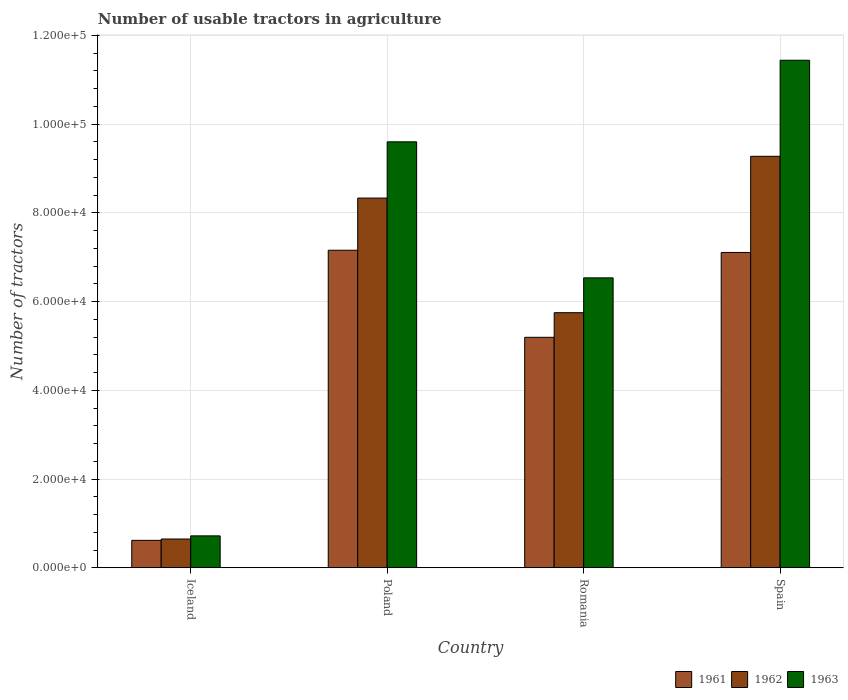How many different coloured bars are there?
Keep it short and to the point. 3. How many bars are there on the 3rd tick from the right?
Your answer should be compact. 3. In how many cases, is the number of bars for a given country not equal to the number of legend labels?
Make the answer very short. 0. What is the number of usable tractors in agriculture in 1963 in Poland?
Make the answer very short. 9.60e+04. Across all countries, what is the maximum number of usable tractors in agriculture in 1961?
Provide a short and direct response. 7.16e+04. Across all countries, what is the minimum number of usable tractors in agriculture in 1961?
Offer a very short reply. 6177. In which country was the number of usable tractors in agriculture in 1961 maximum?
Offer a terse response. Poland. What is the total number of usable tractors in agriculture in 1963 in the graph?
Offer a very short reply. 2.83e+05. What is the difference between the number of usable tractors in agriculture in 1963 in Poland and that in Spain?
Your answer should be compact. -1.84e+04. What is the difference between the number of usable tractors in agriculture in 1961 in Spain and the number of usable tractors in agriculture in 1963 in Romania?
Offer a very short reply. 5726. What is the average number of usable tractors in agriculture in 1961 per country?
Provide a succinct answer. 5.02e+04. What is the difference between the number of usable tractors in agriculture of/in 1963 and number of usable tractors in agriculture of/in 1962 in Spain?
Your answer should be compact. 2.17e+04. In how many countries, is the number of usable tractors in agriculture in 1962 greater than 64000?
Give a very brief answer. 2. What is the ratio of the number of usable tractors in agriculture in 1963 in Iceland to that in Poland?
Make the answer very short. 0.07. Is the number of usable tractors in agriculture in 1962 in Iceland less than that in Poland?
Make the answer very short. Yes. Is the difference between the number of usable tractors in agriculture in 1963 in Poland and Spain greater than the difference between the number of usable tractors in agriculture in 1962 in Poland and Spain?
Your answer should be very brief. No. What is the difference between the highest and the second highest number of usable tractors in agriculture in 1962?
Give a very brief answer. 3.53e+04. What is the difference between the highest and the lowest number of usable tractors in agriculture in 1962?
Offer a very short reply. 8.63e+04. What does the 1st bar from the right in Iceland represents?
Your response must be concise. 1963. Is it the case that in every country, the sum of the number of usable tractors in agriculture in 1962 and number of usable tractors in agriculture in 1961 is greater than the number of usable tractors in agriculture in 1963?
Provide a succinct answer. Yes. Are all the bars in the graph horizontal?
Offer a very short reply. No. What is the difference between two consecutive major ticks on the Y-axis?
Your answer should be compact. 2.00e+04. Are the values on the major ticks of Y-axis written in scientific E-notation?
Provide a succinct answer. Yes. Does the graph contain any zero values?
Keep it short and to the point. No. Does the graph contain grids?
Keep it short and to the point. Yes. Where does the legend appear in the graph?
Offer a very short reply. Bottom right. What is the title of the graph?
Keep it short and to the point. Number of usable tractors in agriculture. Does "1992" appear as one of the legend labels in the graph?
Your answer should be compact. No. What is the label or title of the Y-axis?
Offer a very short reply. Number of tractors. What is the Number of tractors of 1961 in Iceland?
Your answer should be compact. 6177. What is the Number of tractors in 1962 in Iceland?
Offer a terse response. 6479. What is the Number of tractors of 1963 in Iceland?
Keep it short and to the point. 7187. What is the Number of tractors in 1961 in Poland?
Offer a very short reply. 7.16e+04. What is the Number of tractors in 1962 in Poland?
Your answer should be very brief. 8.33e+04. What is the Number of tractors of 1963 in Poland?
Your answer should be compact. 9.60e+04. What is the Number of tractors of 1961 in Romania?
Ensure brevity in your answer.  5.20e+04. What is the Number of tractors of 1962 in Romania?
Make the answer very short. 5.75e+04. What is the Number of tractors in 1963 in Romania?
Your response must be concise. 6.54e+04. What is the Number of tractors in 1961 in Spain?
Provide a succinct answer. 7.11e+04. What is the Number of tractors of 1962 in Spain?
Offer a very short reply. 9.28e+04. What is the Number of tractors of 1963 in Spain?
Ensure brevity in your answer.  1.14e+05. Across all countries, what is the maximum Number of tractors in 1961?
Offer a very short reply. 7.16e+04. Across all countries, what is the maximum Number of tractors of 1962?
Your answer should be compact. 9.28e+04. Across all countries, what is the maximum Number of tractors in 1963?
Provide a short and direct response. 1.14e+05. Across all countries, what is the minimum Number of tractors in 1961?
Your answer should be very brief. 6177. Across all countries, what is the minimum Number of tractors in 1962?
Provide a short and direct response. 6479. Across all countries, what is the minimum Number of tractors of 1963?
Give a very brief answer. 7187. What is the total Number of tractors in 1961 in the graph?
Provide a succinct answer. 2.01e+05. What is the total Number of tractors of 1962 in the graph?
Provide a short and direct response. 2.40e+05. What is the total Number of tractors of 1963 in the graph?
Your answer should be very brief. 2.83e+05. What is the difference between the Number of tractors in 1961 in Iceland and that in Poland?
Provide a short and direct response. -6.54e+04. What is the difference between the Number of tractors in 1962 in Iceland and that in Poland?
Keep it short and to the point. -7.69e+04. What is the difference between the Number of tractors of 1963 in Iceland and that in Poland?
Keep it short and to the point. -8.88e+04. What is the difference between the Number of tractors in 1961 in Iceland and that in Romania?
Your answer should be very brief. -4.58e+04. What is the difference between the Number of tractors in 1962 in Iceland and that in Romania?
Provide a succinct answer. -5.10e+04. What is the difference between the Number of tractors of 1963 in Iceland and that in Romania?
Give a very brief answer. -5.82e+04. What is the difference between the Number of tractors in 1961 in Iceland and that in Spain?
Provide a short and direct response. -6.49e+04. What is the difference between the Number of tractors in 1962 in Iceland and that in Spain?
Provide a succinct answer. -8.63e+04. What is the difference between the Number of tractors in 1963 in Iceland and that in Spain?
Keep it short and to the point. -1.07e+05. What is the difference between the Number of tractors of 1961 in Poland and that in Romania?
Your answer should be compact. 1.96e+04. What is the difference between the Number of tractors in 1962 in Poland and that in Romania?
Provide a succinct answer. 2.58e+04. What is the difference between the Number of tractors of 1963 in Poland and that in Romania?
Provide a succinct answer. 3.07e+04. What is the difference between the Number of tractors of 1962 in Poland and that in Spain?
Make the answer very short. -9414. What is the difference between the Number of tractors of 1963 in Poland and that in Spain?
Your answer should be very brief. -1.84e+04. What is the difference between the Number of tractors in 1961 in Romania and that in Spain?
Your answer should be compact. -1.91e+04. What is the difference between the Number of tractors of 1962 in Romania and that in Spain?
Your response must be concise. -3.53e+04. What is the difference between the Number of tractors in 1963 in Romania and that in Spain?
Your answer should be compact. -4.91e+04. What is the difference between the Number of tractors in 1961 in Iceland and the Number of tractors in 1962 in Poland?
Your response must be concise. -7.72e+04. What is the difference between the Number of tractors in 1961 in Iceland and the Number of tractors in 1963 in Poland?
Offer a terse response. -8.98e+04. What is the difference between the Number of tractors in 1962 in Iceland and the Number of tractors in 1963 in Poland?
Your answer should be very brief. -8.95e+04. What is the difference between the Number of tractors in 1961 in Iceland and the Number of tractors in 1962 in Romania?
Ensure brevity in your answer.  -5.13e+04. What is the difference between the Number of tractors of 1961 in Iceland and the Number of tractors of 1963 in Romania?
Keep it short and to the point. -5.92e+04. What is the difference between the Number of tractors of 1962 in Iceland and the Number of tractors of 1963 in Romania?
Offer a terse response. -5.89e+04. What is the difference between the Number of tractors in 1961 in Iceland and the Number of tractors in 1962 in Spain?
Ensure brevity in your answer.  -8.66e+04. What is the difference between the Number of tractors in 1961 in Iceland and the Number of tractors in 1963 in Spain?
Offer a very short reply. -1.08e+05. What is the difference between the Number of tractors in 1962 in Iceland and the Number of tractors in 1963 in Spain?
Your response must be concise. -1.08e+05. What is the difference between the Number of tractors in 1961 in Poland and the Number of tractors in 1962 in Romania?
Provide a short and direct response. 1.41e+04. What is the difference between the Number of tractors in 1961 in Poland and the Number of tractors in 1963 in Romania?
Keep it short and to the point. 6226. What is the difference between the Number of tractors in 1962 in Poland and the Number of tractors in 1963 in Romania?
Provide a succinct answer. 1.80e+04. What is the difference between the Number of tractors in 1961 in Poland and the Number of tractors in 1962 in Spain?
Provide a short and direct response. -2.12e+04. What is the difference between the Number of tractors of 1961 in Poland and the Number of tractors of 1963 in Spain?
Offer a very short reply. -4.28e+04. What is the difference between the Number of tractors of 1962 in Poland and the Number of tractors of 1963 in Spain?
Make the answer very short. -3.11e+04. What is the difference between the Number of tractors in 1961 in Romania and the Number of tractors in 1962 in Spain?
Your response must be concise. -4.08e+04. What is the difference between the Number of tractors of 1961 in Romania and the Number of tractors of 1963 in Spain?
Ensure brevity in your answer.  -6.25e+04. What is the difference between the Number of tractors of 1962 in Romania and the Number of tractors of 1963 in Spain?
Ensure brevity in your answer.  -5.69e+04. What is the average Number of tractors of 1961 per country?
Give a very brief answer. 5.02e+04. What is the average Number of tractors of 1962 per country?
Make the answer very short. 6.00e+04. What is the average Number of tractors in 1963 per country?
Give a very brief answer. 7.07e+04. What is the difference between the Number of tractors of 1961 and Number of tractors of 1962 in Iceland?
Your response must be concise. -302. What is the difference between the Number of tractors of 1961 and Number of tractors of 1963 in Iceland?
Ensure brevity in your answer.  -1010. What is the difference between the Number of tractors of 1962 and Number of tractors of 1963 in Iceland?
Ensure brevity in your answer.  -708. What is the difference between the Number of tractors in 1961 and Number of tractors in 1962 in Poland?
Offer a terse response. -1.18e+04. What is the difference between the Number of tractors of 1961 and Number of tractors of 1963 in Poland?
Provide a succinct answer. -2.44e+04. What is the difference between the Number of tractors of 1962 and Number of tractors of 1963 in Poland?
Ensure brevity in your answer.  -1.27e+04. What is the difference between the Number of tractors in 1961 and Number of tractors in 1962 in Romania?
Make the answer very short. -5548. What is the difference between the Number of tractors in 1961 and Number of tractors in 1963 in Romania?
Provide a short and direct response. -1.34e+04. What is the difference between the Number of tractors of 1962 and Number of tractors of 1963 in Romania?
Provide a succinct answer. -7851. What is the difference between the Number of tractors in 1961 and Number of tractors in 1962 in Spain?
Give a very brief answer. -2.17e+04. What is the difference between the Number of tractors in 1961 and Number of tractors in 1963 in Spain?
Keep it short and to the point. -4.33e+04. What is the difference between the Number of tractors of 1962 and Number of tractors of 1963 in Spain?
Offer a terse response. -2.17e+04. What is the ratio of the Number of tractors of 1961 in Iceland to that in Poland?
Provide a short and direct response. 0.09. What is the ratio of the Number of tractors of 1962 in Iceland to that in Poland?
Your response must be concise. 0.08. What is the ratio of the Number of tractors in 1963 in Iceland to that in Poland?
Provide a short and direct response. 0.07. What is the ratio of the Number of tractors in 1961 in Iceland to that in Romania?
Offer a terse response. 0.12. What is the ratio of the Number of tractors in 1962 in Iceland to that in Romania?
Make the answer very short. 0.11. What is the ratio of the Number of tractors of 1963 in Iceland to that in Romania?
Your response must be concise. 0.11. What is the ratio of the Number of tractors in 1961 in Iceland to that in Spain?
Your response must be concise. 0.09. What is the ratio of the Number of tractors in 1962 in Iceland to that in Spain?
Your response must be concise. 0.07. What is the ratio of the Number of tractors in 1963 in Iceland to that in Spain?
Your answer should be very brief. 0.06. What is the ratio of the Number of tractors of 1961 in Poland to that in Romania?
Your response must be concise. 1.38. What is the ratio of the Number of tractors in 1962 in Poland to that in Romania?
Offer a very short reply. 1.45. What is the ratio of the Number of tractors in 1963 in Poland to that in Romania?
Your response must be concise. 1.47. What is the ratio of the Number of tractors of 1961 in Poland to that in Spain?
Provide a succinct answer. 1.01. What is the ratio of the Number of tractors of 1962 in Poland to that in Spain?
Provide a succinct answer. 0.9. What is the ratio of the Number of tractors of 1963 in Poland to that in Spain?
Make the answer very short. 0.84. What is the ratio of the Number of tractors in 1961 in Romania to that in Spain?
Offer a terse response. 0.73. What is the ratio of the Number of tractors of 1962 in Romania to that in Spain?
Your answer should be compact. 0.62. What is the ratio of the Number of tractors in 1963 in Romania to that in Spain?
Your response must be concise. 0.57. What is the difference between the highest and the second highest Number of tractors of 1962?
Provide a succinct answer. 9414. What is the difference between the highest and the second highest Number of tractors in 1963?
Provide a short and direct response. 1.84e+04. What is the difference between the highest and the lowest Number of tractors of 1961?
Give a very brief answer. 6.54e+04. What is the difference between the highest and the lowest Number of tractors in 1962?
Provide a succinct answer. 8.63e+04. What is the difference between the highest and the lowest Number of tractors of 1963?
Your response must be concise. 1.07e+05. 